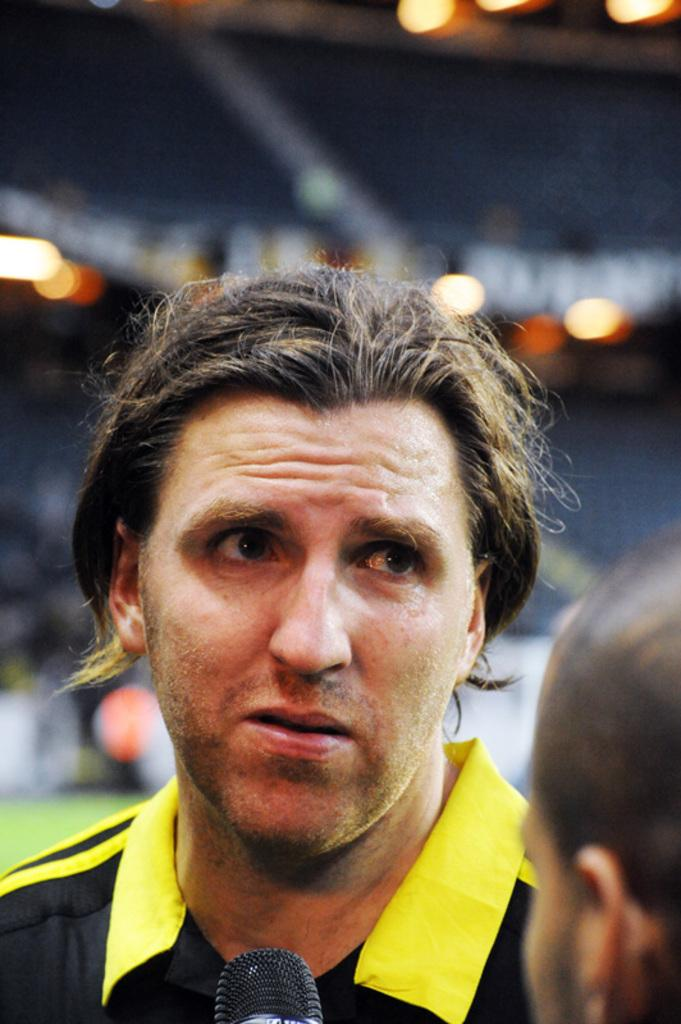How many people are present in the image? There are two people in the image. What can be observed about the background of the image? The background of the image is blurred. What object is visible in the image that is commonly used for amplifying sound? There is a microphone in the image. What type of plastic material is covering the van in the image? There is no van present in the image, and therefore no plastic material covering it. How low is the sound in the image? The sound cannot be determined from the image, as it is a visual medium. 